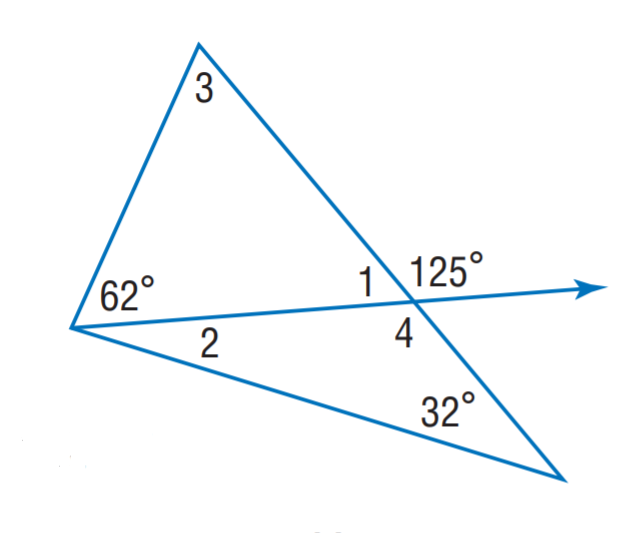Answer the mathemtical geometry problem and directly provide the correct option letter.
Question: Find m \angle 2.
Choices: A: 23 B: 55 C: 63 D: 125 A 